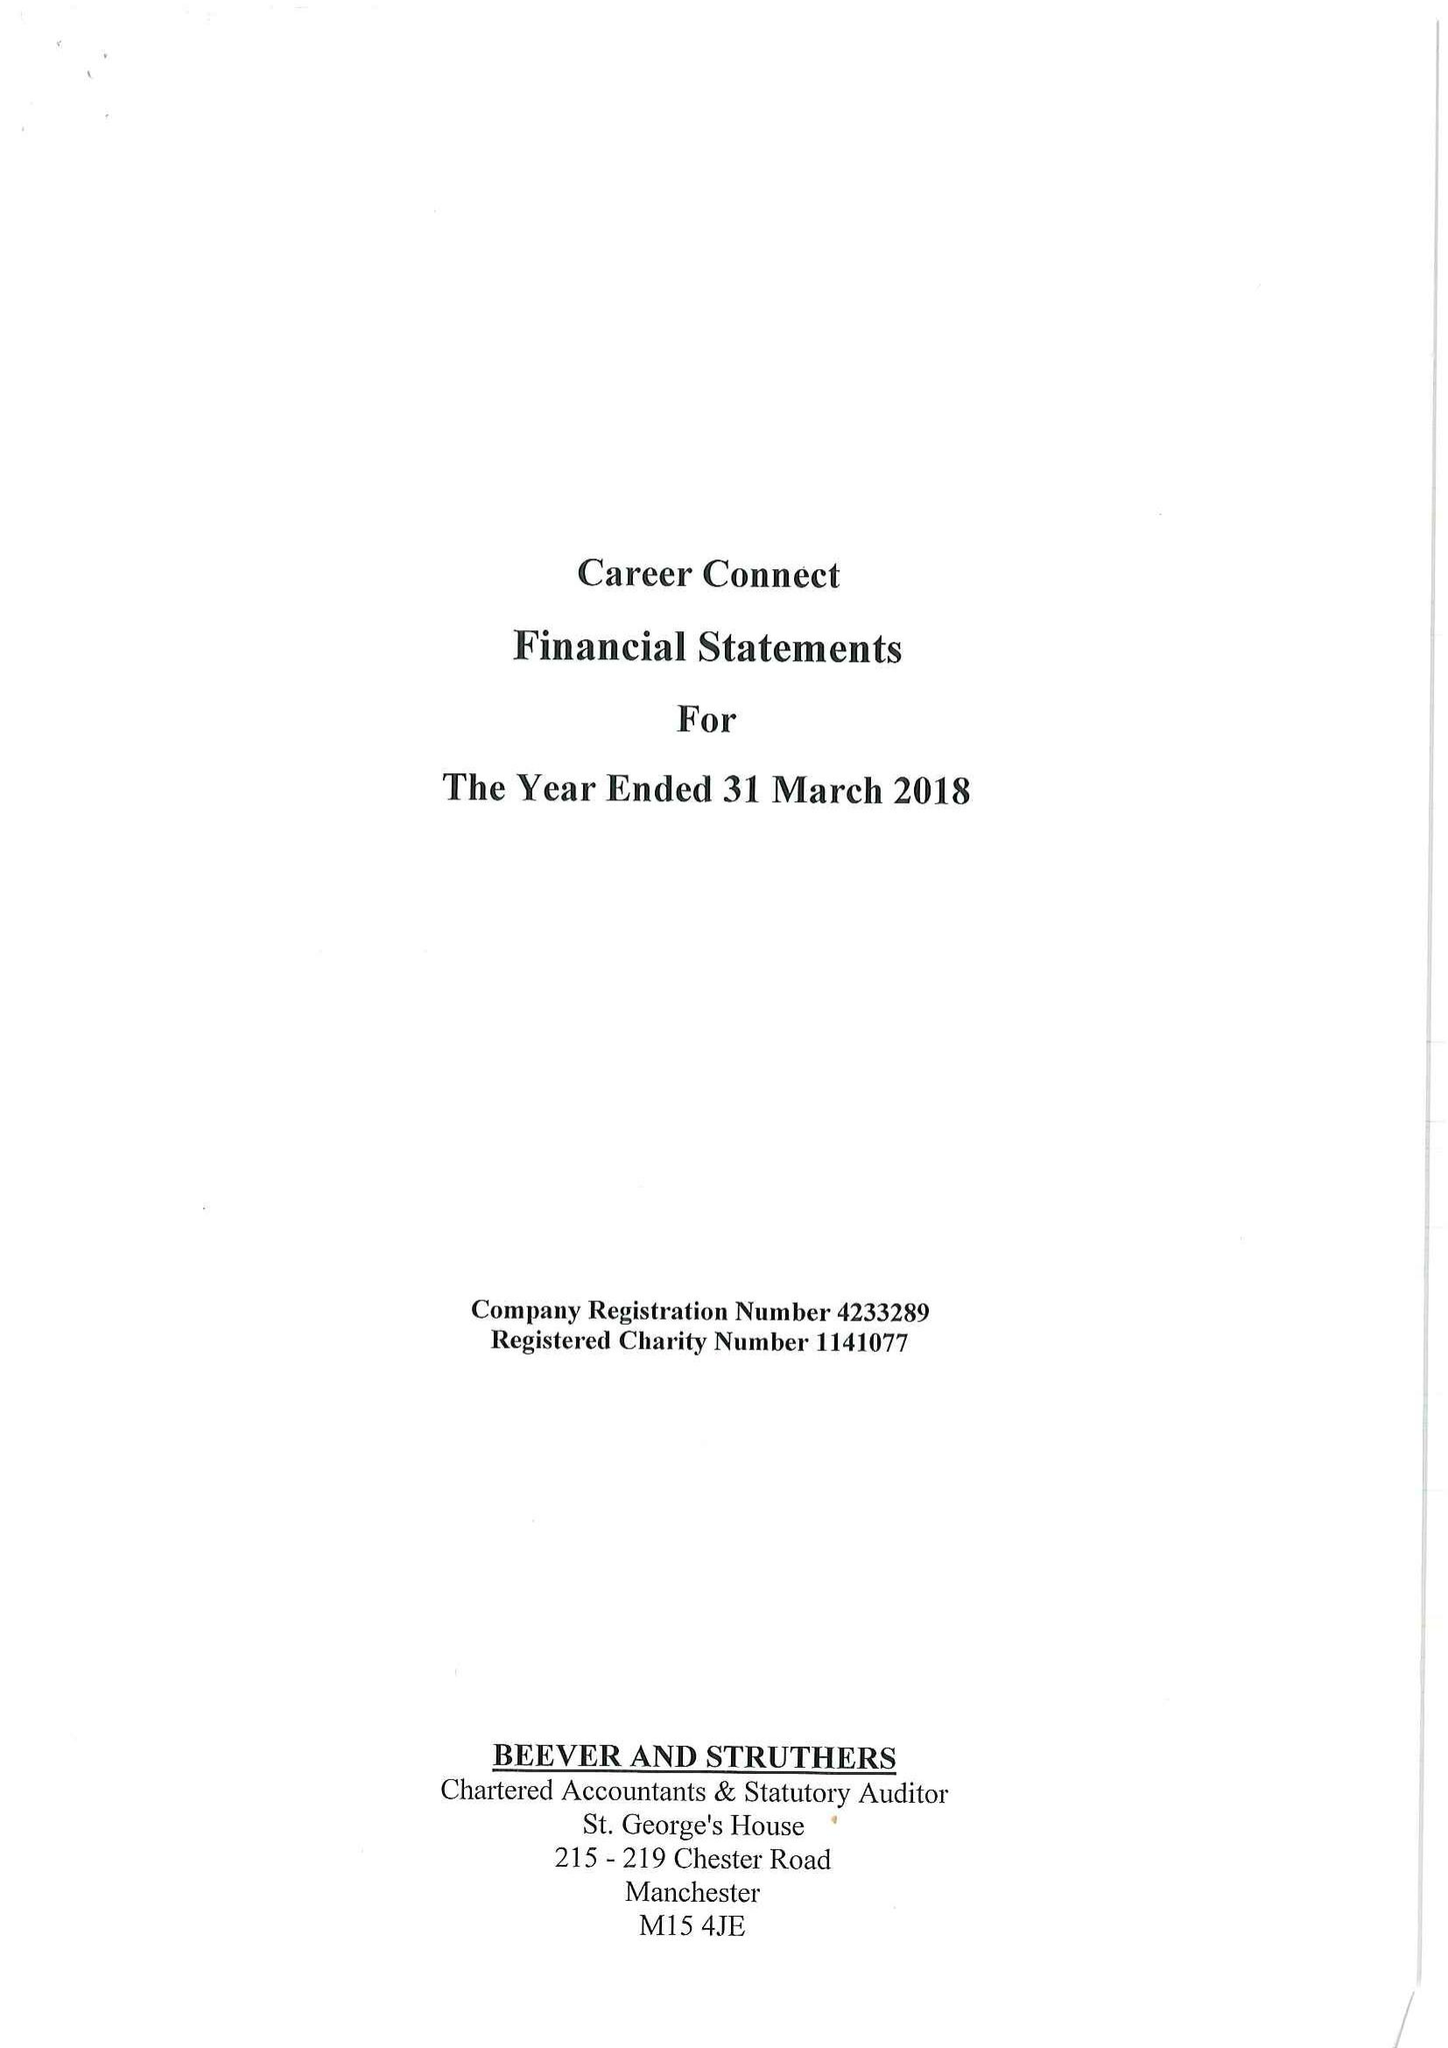What is the value for the charity_name?
Answer the question using a single word or phrase. Career Connect 